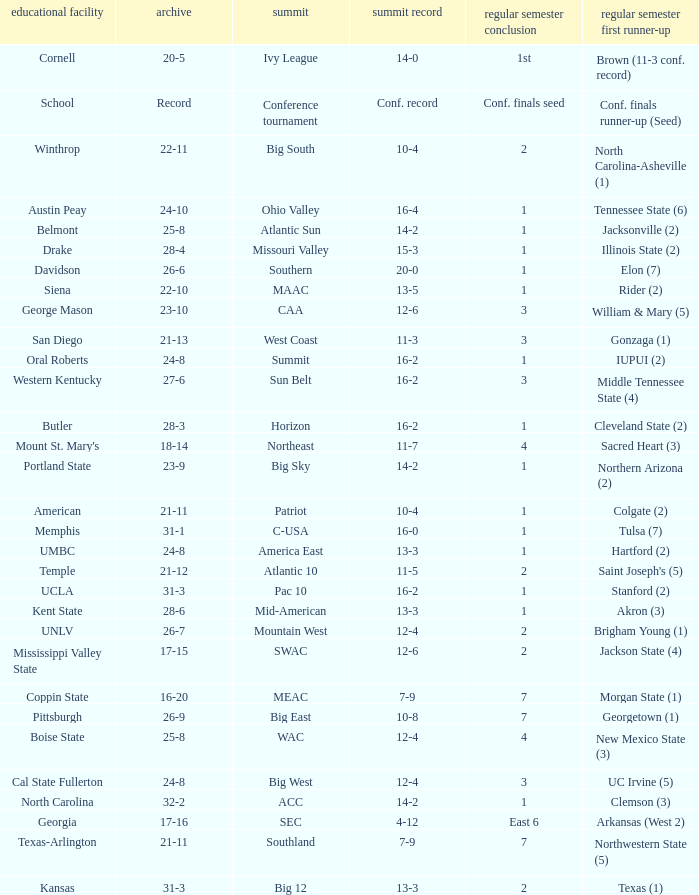What was the overall record of Oral Roberts college? 24-8. 